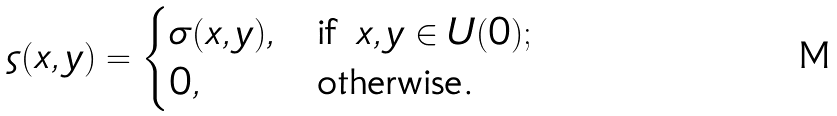<formula> <loc_0><loc_0><loc_500><loc_500>\varsigma ( x , y ) = \begin{cases} \sigma ( x , y ) , & \text {if } x , y \in U ( 0 ) ; \\ 0 , & \text {otherwise.} \end{cases}</formula> 